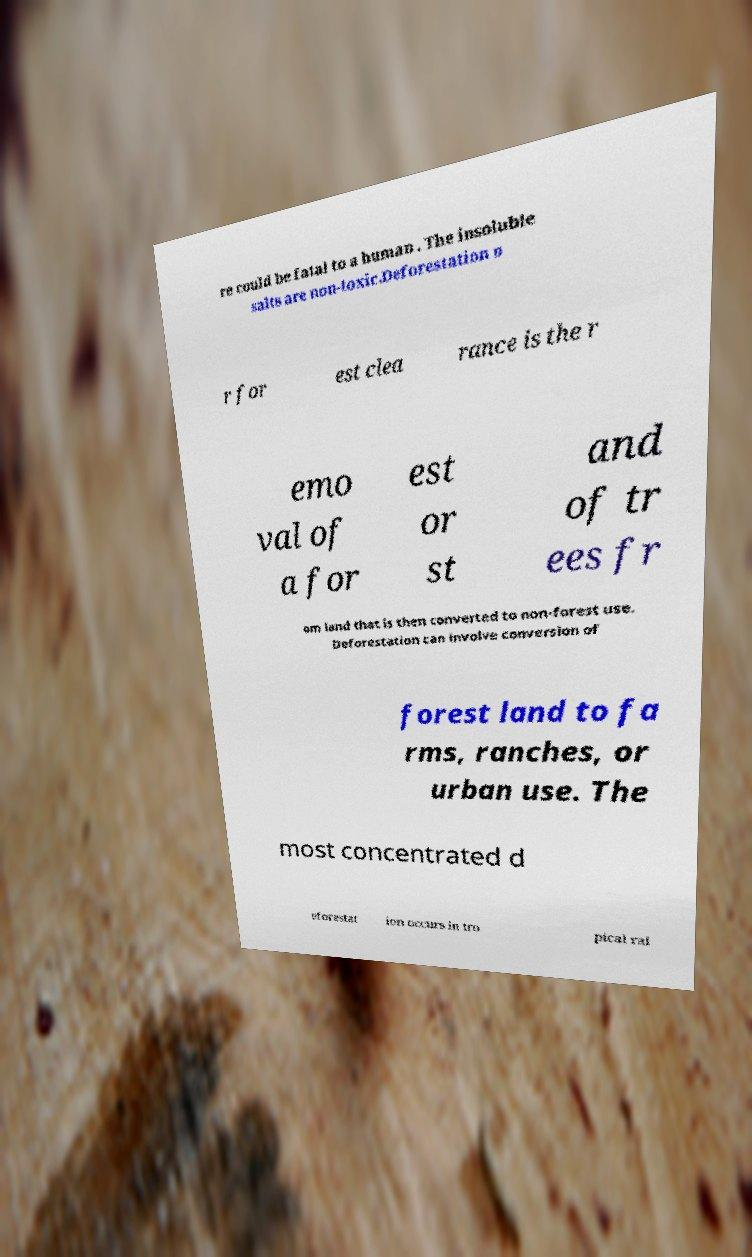Please identify and transcribe the text found in this image. re could be fatal to a human . The insoluble salts are non-toxic.Deforestation o r for est clea rance is the r emo val of a for est or st and of tr ees fr om land that is then converted to non-forest use. Deforestation can involve conversion of forest land to fa rms, ranches, or urban use. The most concentrated d eforestat ion occurs in tro pical rai 